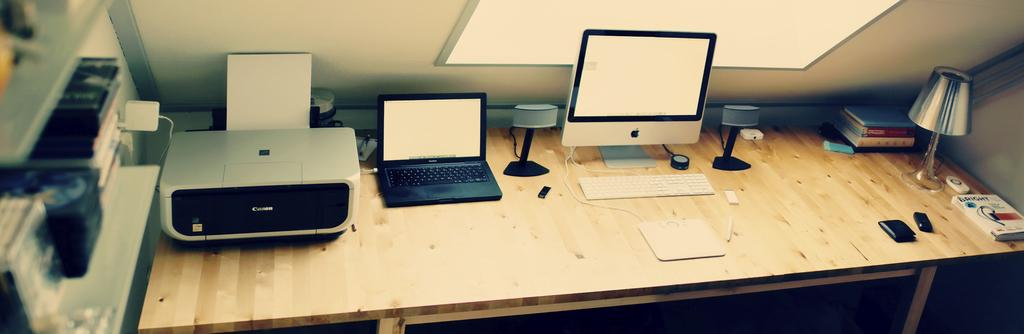What type of device is present in the image? There is a printer, a laptop, speakers, a monitor, and a keyboard present in the image. What might be used for inputting data in the image? The keyboard in the image might be used for inputting data. What might be used for displaying visual information in the image? The monitor in the image might be used for displaying visual information. What might be used for producing sound in the image? The speakers in the image might be used for producing sound. What type of coin can be seen on the laptop in the image? There is no coin, including a dime, present on the laptop in the image. What type of bodily function is being performed by the printer in the image? The printer is an inanimate object and does not perform bodily functions like coughing or digestion. 